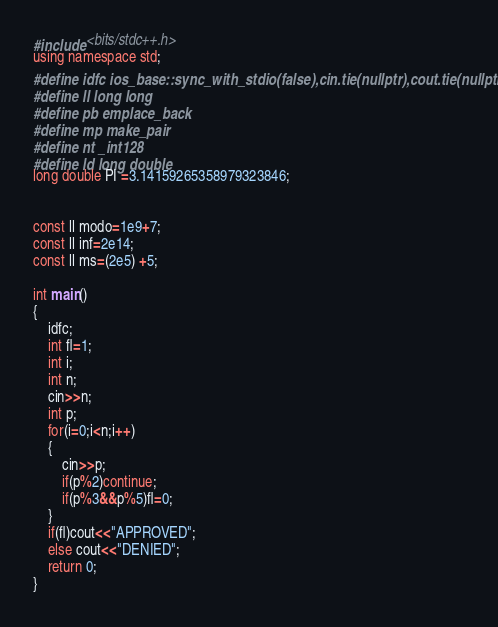Convert code to text. <code><loc_0><loc_0><loc_500><loc_500><_C++_>#include <bits/stdc++.h>
using namespace std;
#define idfc ios_base::sync_with_stdio(false),cin.tie(nullptr),cout.tie(nullptr)
#define ll long long
#define pb emplace_back
#define mp make_pair
#define nt _int128
#define ld long double
long double PI =3.14159265358979323846;


const ll modo=1e9+7;
const ll inf=2e14;
const ll ms=(2e5) +5;

int main()
{
    idfc;
    int fl=1;
    int i;
    int n;
    cin>>n;
    int p;
    for(i=0;i<n;i++)
    {
        cin>>p;
        if(p%2)continue;
        if(p%3&&p%5)fl=0;
    }
    if(fl)cout<<"APPROVED";
    else cout<<"DENIED";
    return 0;
}</code> 